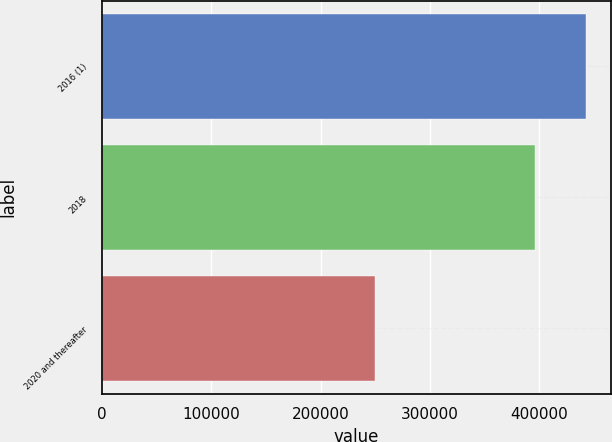<chart> <loc_0><loc_0><loc_500><loc_500><bar_chart><fcel>2016 (1)<fcel>2018<fcel>2020 and thereafter<nl><fcel>442941<fcel>396000<fcel>250000<nl></chart> 